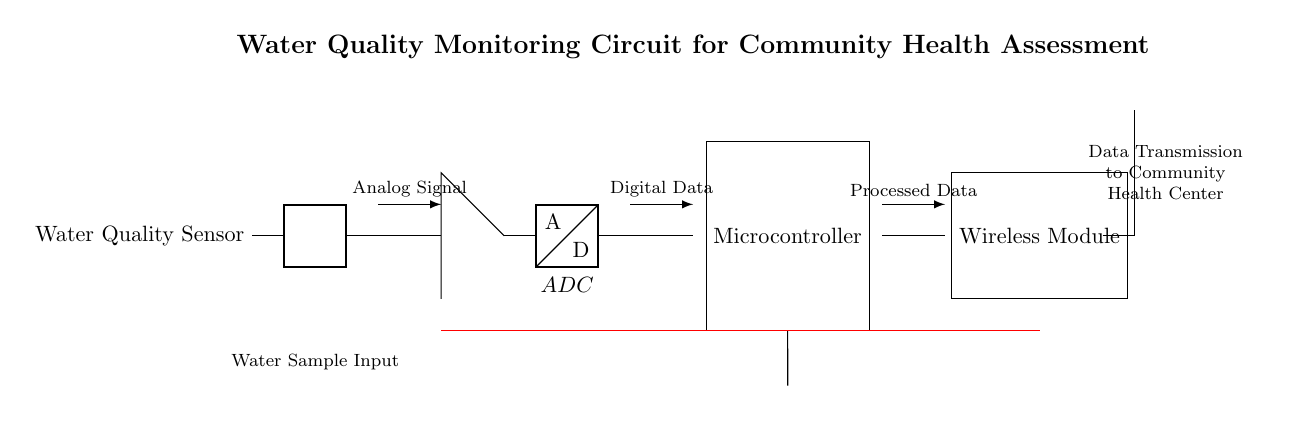What is the type of the first component in the circuit? The first component is a Water Quality Sensor as indicated in the circuit diagram.
Answer: Water Quality Sensor How many main functional blocks are there in the circuit? The main functional blocks are the sensor, amplifier, ADC, microcontroller, and wireless module, totaling five blocks.
Answer: Five What type of signal does the ADC block process? The ADC block processes an analog signal, as depicted by the arrow labeled "Analog Signal" pointing towards it.
Answer: Analog Signal What is the role of the microcontroller in this circuit? The microcontroller is responsible for processing digital data received from the ADC, as it receives input directly from it and delivers output to the wireless module.
Answer: Processing digital data If a battery is used, what is its function in this circuit? The battery serves as the power supply for the circuit, providing the necessary voltage and current for operation as shown in the schematic's power connections.
Answer: Power supply Why is there a need for a wireless module in this circuit? The wireless module is essential for transmitting processed data to the community health center, facilitating the communication of water quality data without physical connections.
Answer: Data transmission 